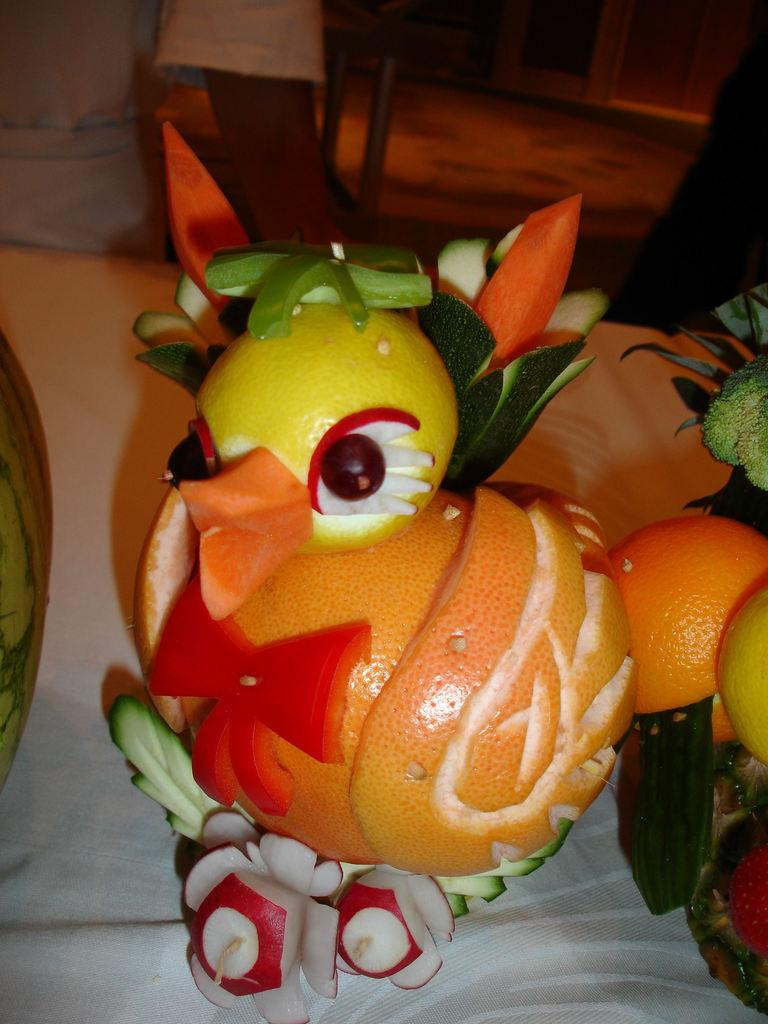What type of food can be seen in the image? There are fruits in the image. How are the fruits arranged or presented in the image? The fruits are decorated to resemble a bird. What type of jar is visible in the image? There is no jar present in the image. What type of pets can be seen playing in the field in the image? There is no field or pets present in the image. 